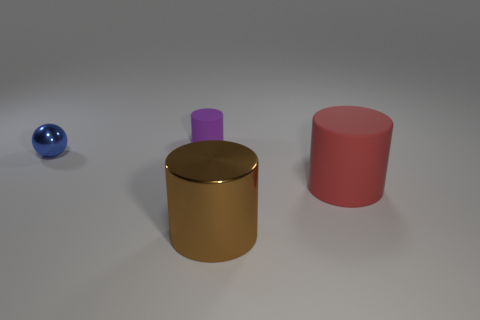Add 3 small blue metal spheres. How many objects exist? 7 Subtract all matte cylinders. How many cylinders are left? 1 Subtract 3 cylinders. How many cylinders are left? 0 Subtract all purple cylinders. How many cylinders are left? 2 Subtract 0 gray cubes. How many objects are left? 4 Subtract all cylinders. How many objects are left? 1 Subtract all brown cylinders. Subtract all yellow blocks. How many cylinders are left? 2 Subtract all blue blocks. How many purple cylinders are left? 1 Subtract all big red cylinders. Subtract all big rubber objects. How many objects are left? 2 Add 2 blue metal spheres. How many blue metal spheres are left? 3 